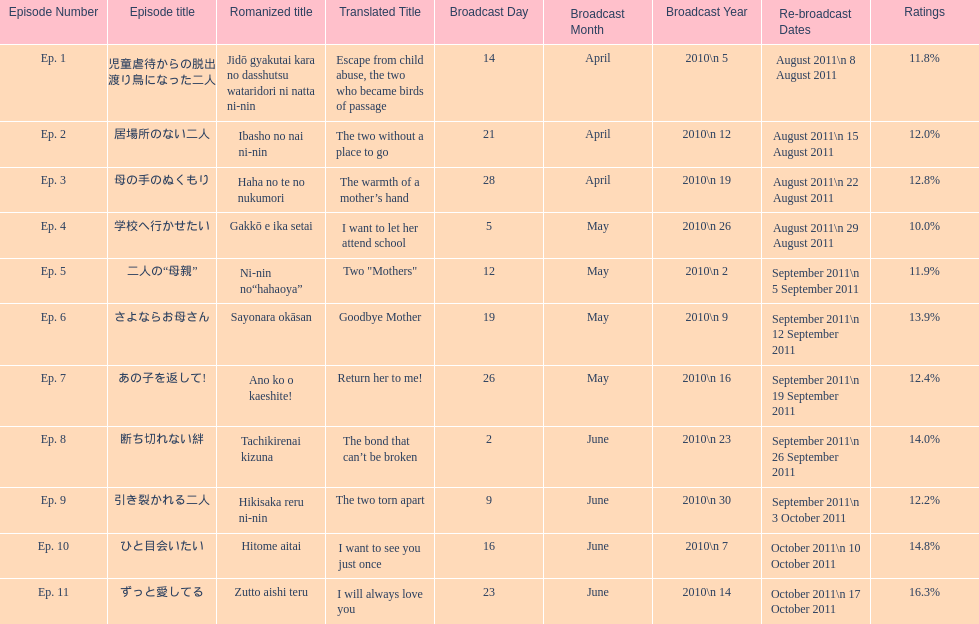What was the top rated episode of this show? ずっと愛してる. 